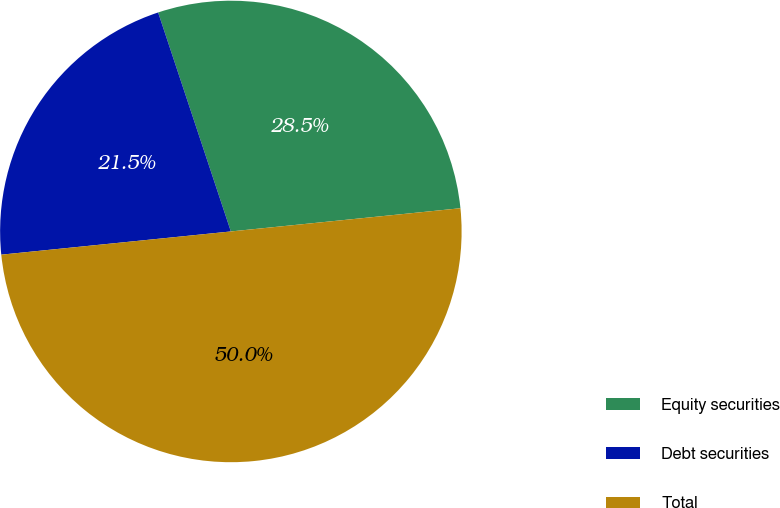Convert chart to OTSL. <chart><loc_0><loc_0><loc_500><loc_500><pie_chart><fcel>Equity securities<fcel>Debt securities<fcel>Total<nl><fcel>28.5%<fcel>21.5%<fcel>50.0%<nl></chart> 